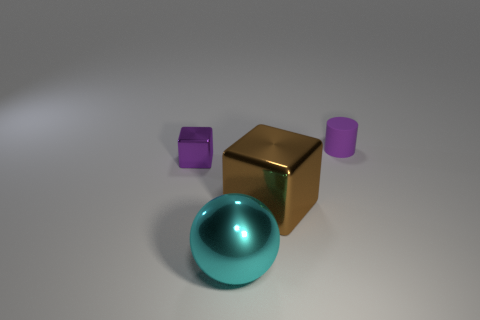The metallic object that is the same color as the cylinder is what shape?
Your answer should be compact. Cube. There is a cyan thing that is the same size as the brown shiny thing; what shape is it?
Offer a very short reply. Sphere. Does the small purple rubber thing have the same shape as the brown metallic thing?
Ensure brevity in your answer.  No. Is the number of purple cylinders in front of the big brown shiny thing the same as the number of big cyan metallic objects?
Ensure brevity in your answer.  No. How many other objects are the same material as the tiny purple block?
Keep it short and to the point. 2. Do the cyan metal thing that is to the left of the tiny matte cylinder and the shiny cube that is right of the ball have the same size?
Provide a short and direct response. Yes. What number of things are purple things behind the tiny purple metallic object or objects in front of the big brown object?
Provide a short and direct response. 2. Is there anything else that has the same shape as the cyan thing?
Ensure brevity in your answer.  No. Does the shiny object in front of the brown shiny block have the same color as the cube that is on the left side of the big brown metallic object?
Your response must be concise. No. What number of matte objects are either big blocks or large yellow balls?
Give a very brief answer. 0. 